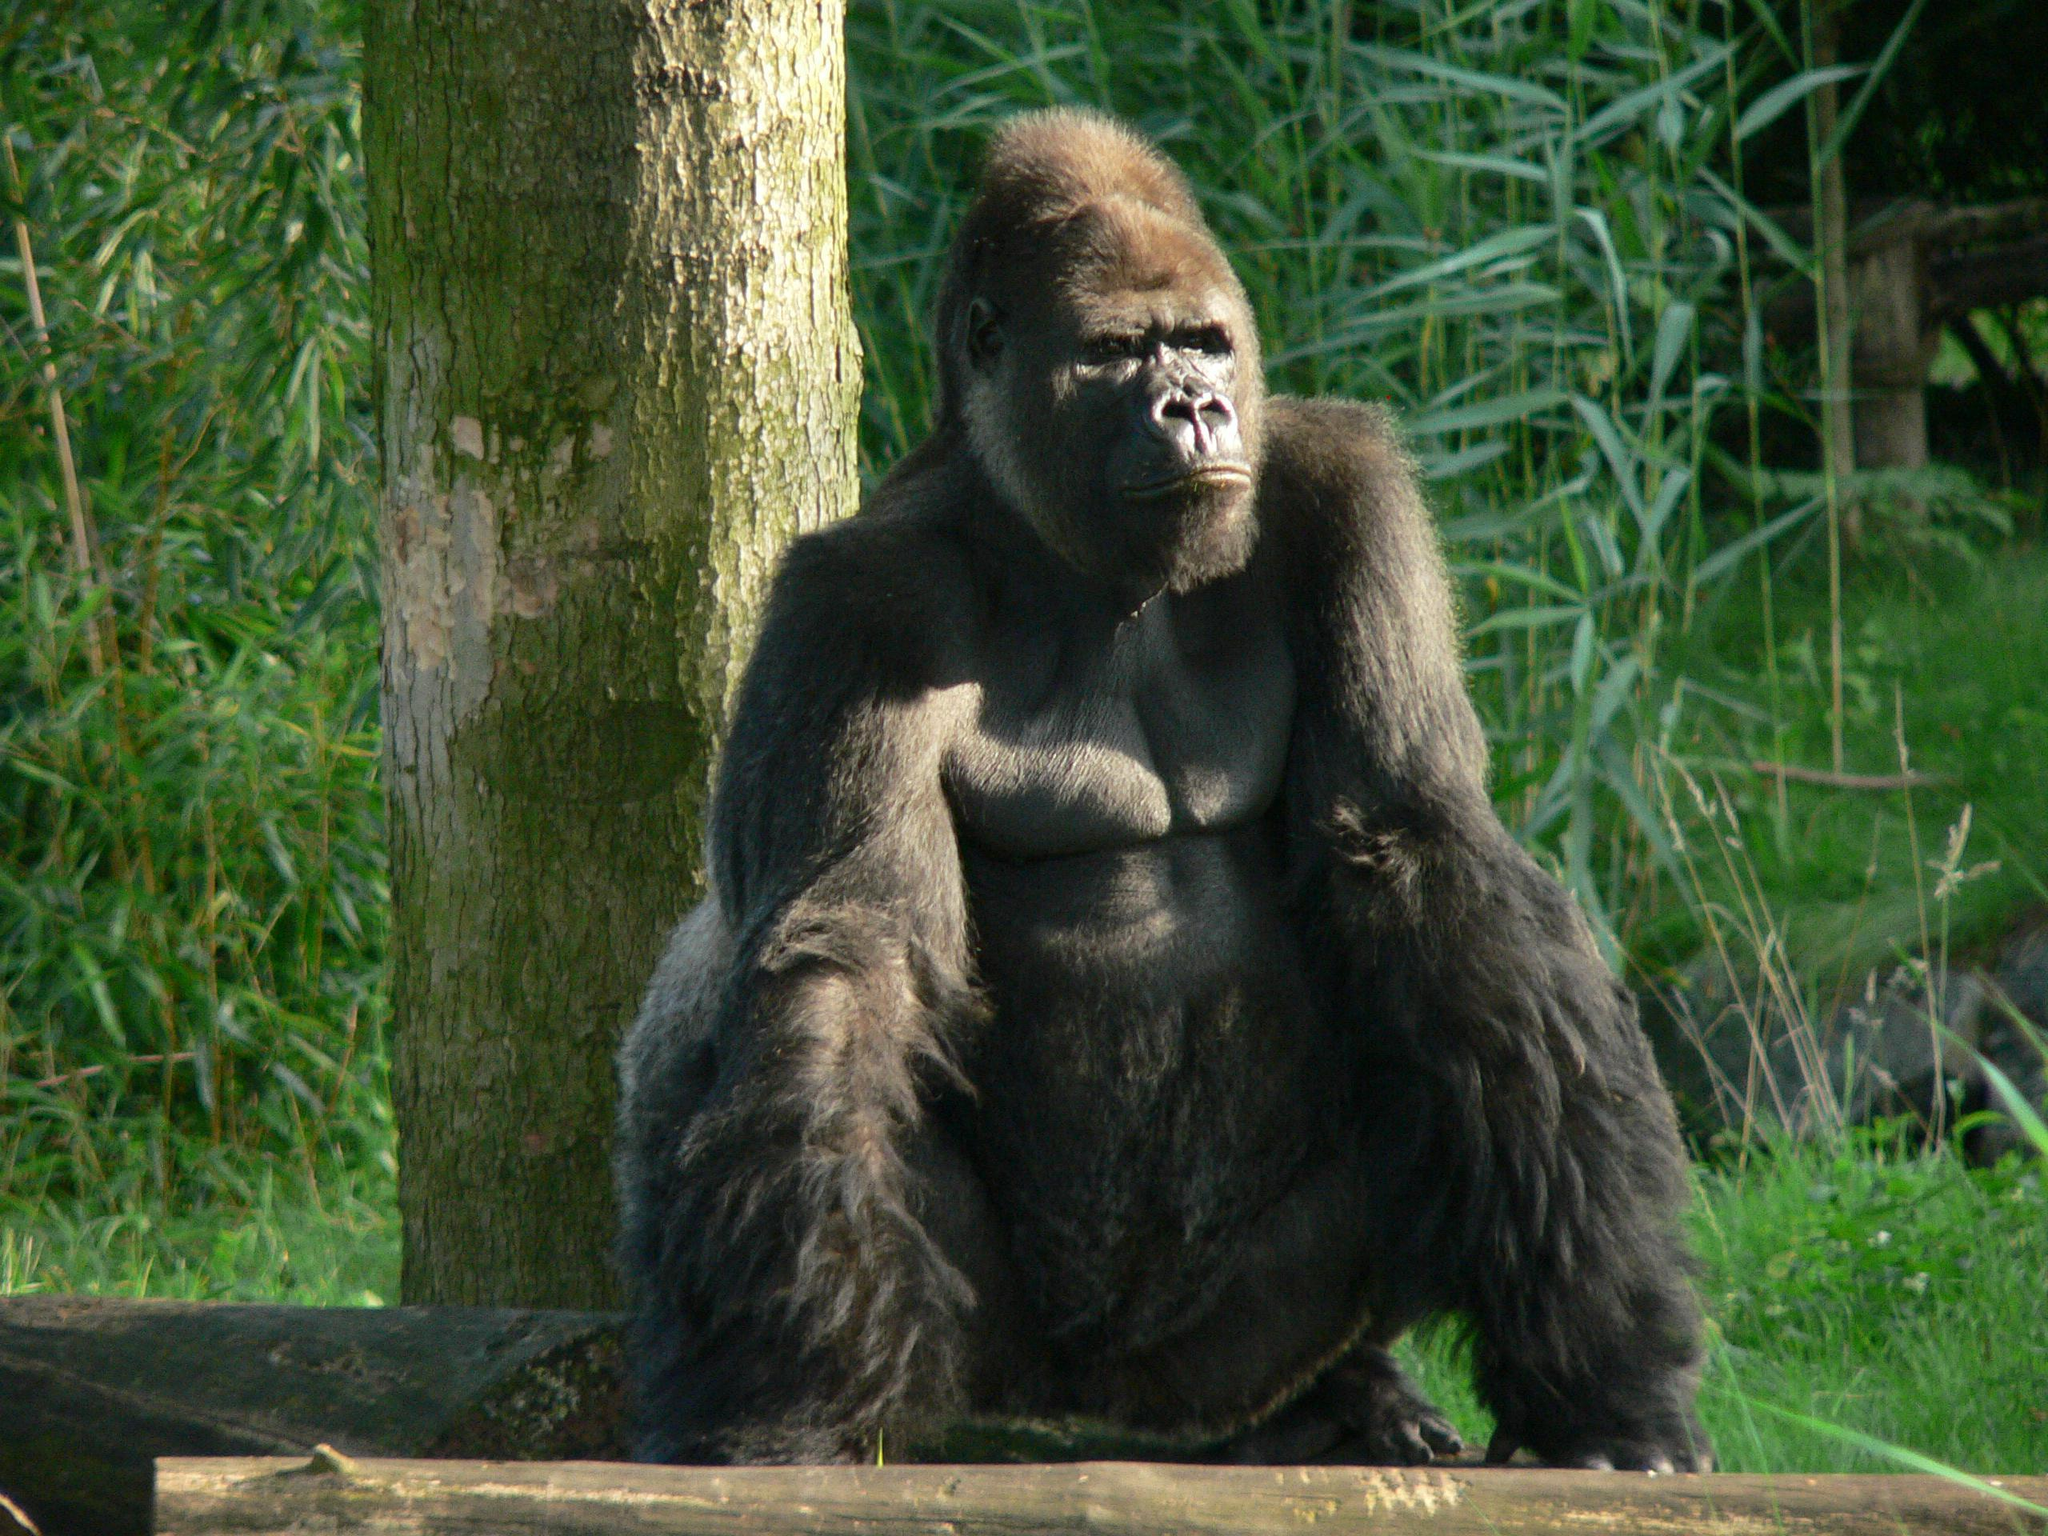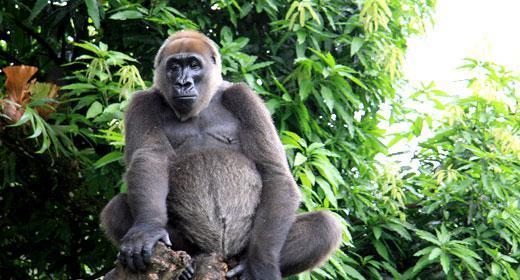The first image is the image on the left, the second image is the image on the right. Given the left and right images, does the statement "There are no more than two apes in total." hold true? Answer yes or no. Yes. The first image is the image on the left, the second image is the image on the right. Assess this claim about the two images: "There are exactly two gorillas in total.". Correct or not? Answer yes or no. Yes. 